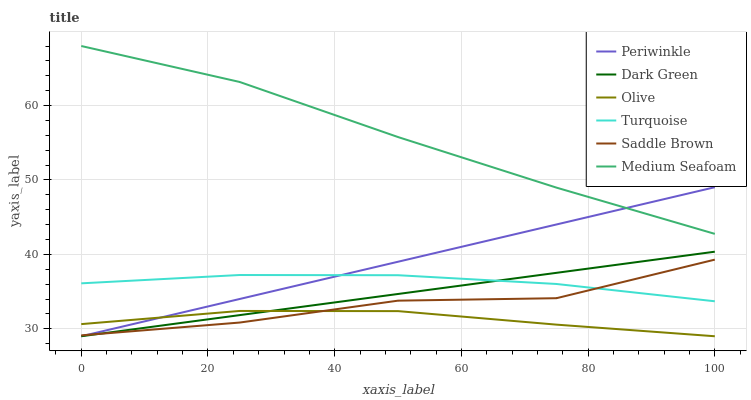Does Olive have the minimum area under the curve?
Answer yes or no. Yes. Does Medium Seafoam have the maximum area under the curve?
Answer yes or no. Yes. Does Saddle Brown have the minimum area under the curve?
Answer yes or no. No. Does Saddle Brown have the maximum area under the curve?
Answer yes or no. No. Is Periwinkle the smoothest?
Answer yes or no. Yes. Is Saddle Brown the roughest?
Answer yes or no. Yes. Is Saddle Brown the smoothest?
Answer yes or no. No. Is Periwinkle the roughest?
Answer yes or no. No. Does Periwinkle have the lowest value?
Answer yes or no. Yes. Does Saddle Brown have the lowest value?
Answer yes or no. No. Does Medium Seafoam have the highest value?
Answer yes or no. Yes. Does Saddle Brown have the highest value?
Answer yes or no. No. Is Saddle Brown less than Medium Seafoam?
Answer yes or no. Yes. Is Medium Seafoam greater than Olive?
Answer yes or no. Yes. Does Dark Green intersect Turquoise?
Answer yes or no. Yes. Is Dark Green less than Turquoise?
Answer yes or no. No. Is Dark Green greater than Turquoise?
Answer yes or no. No. Does Saddle Brown intersect Medium Seafoam?
Answer yes or no. No. 